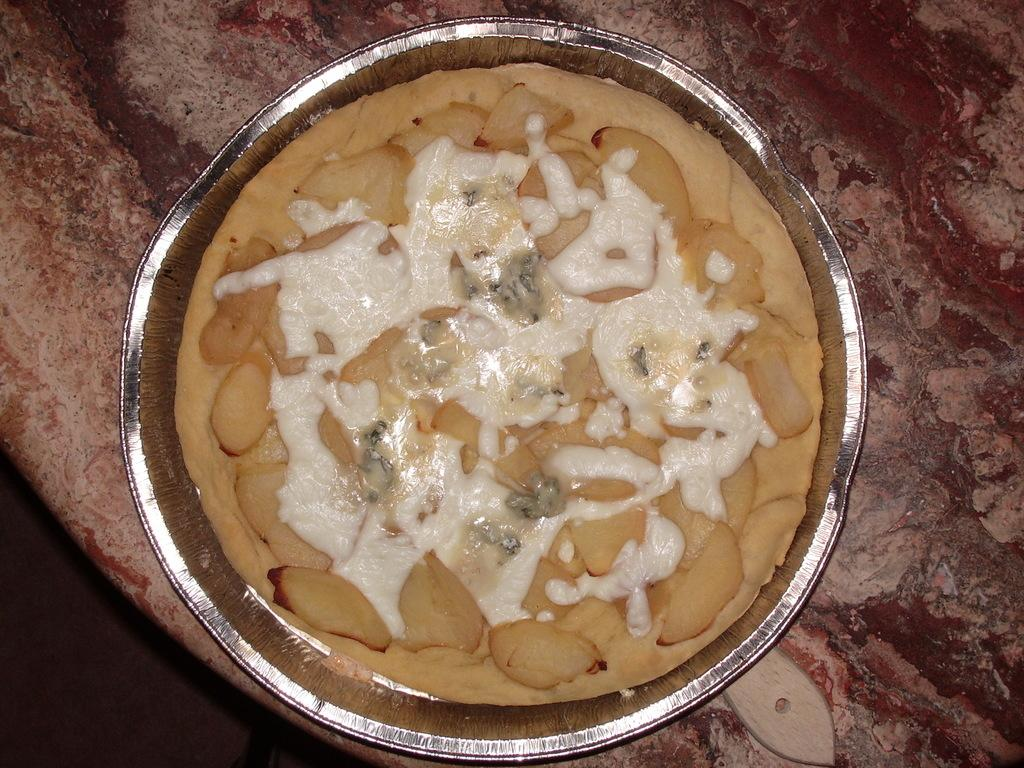What is present in the image? There is a container in the image. What is inside the container? There is a food item in the container. What type of shade is covering the car in the image? There is no car or shade present in the image; it only features a container with a food item inside. 